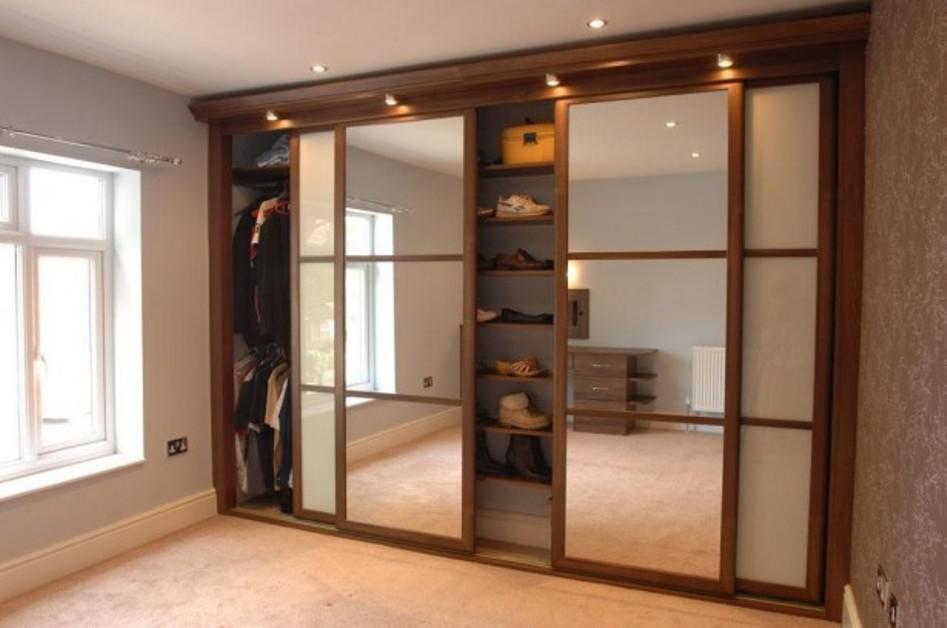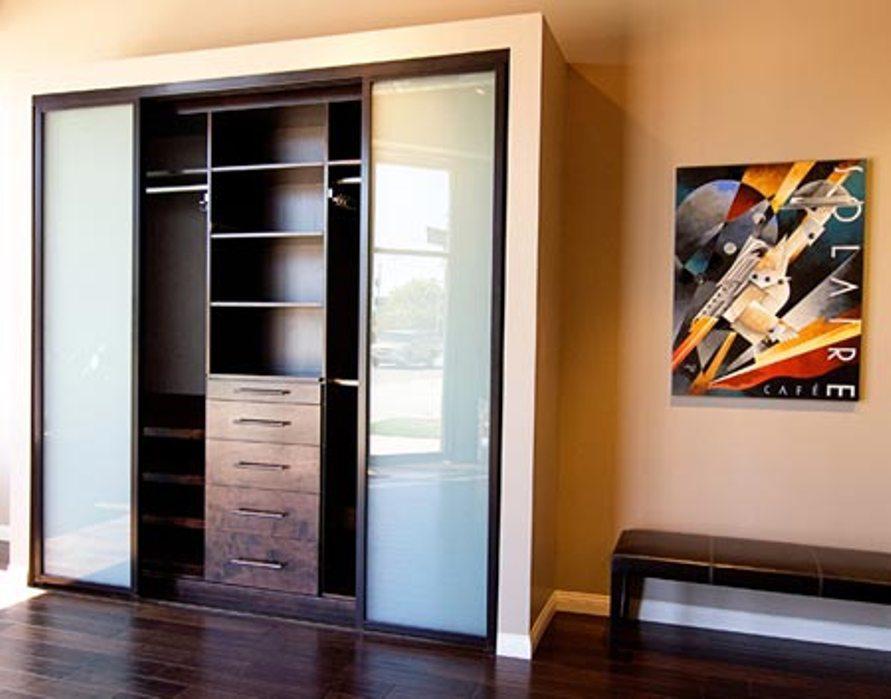The first image is the image on the left, the second image is the image on the right. For the images shown, is this caption "The left and right image contains a total of three brown wooden hanging doors." true? Answer yes or no. No. The first image is the image on the left, the second image is the image on the right. Assess this claim about the two images: "The left image features a wide-open sliding 'barn style' wooden double door with a black bar at the top, and the right image shows a single barn-style wood plank door.". Correct or not? Answer yes or no. No. The first image is the image on the left, the second image is the image on the right. Assess this claim about the two images: "The left image features a 'barn style' wood-paneled double door with a black bar at the top, and the right image shows a single barn-style wood plank door.". Correct or not? Answer yes or no. No. The first image is the image on the left, the second image is the image on the right. Examine the images to the left and right. Is the description "The left and right image contains a total of three brown wooden hanging doors." accurate? Answer yes or no. No. 